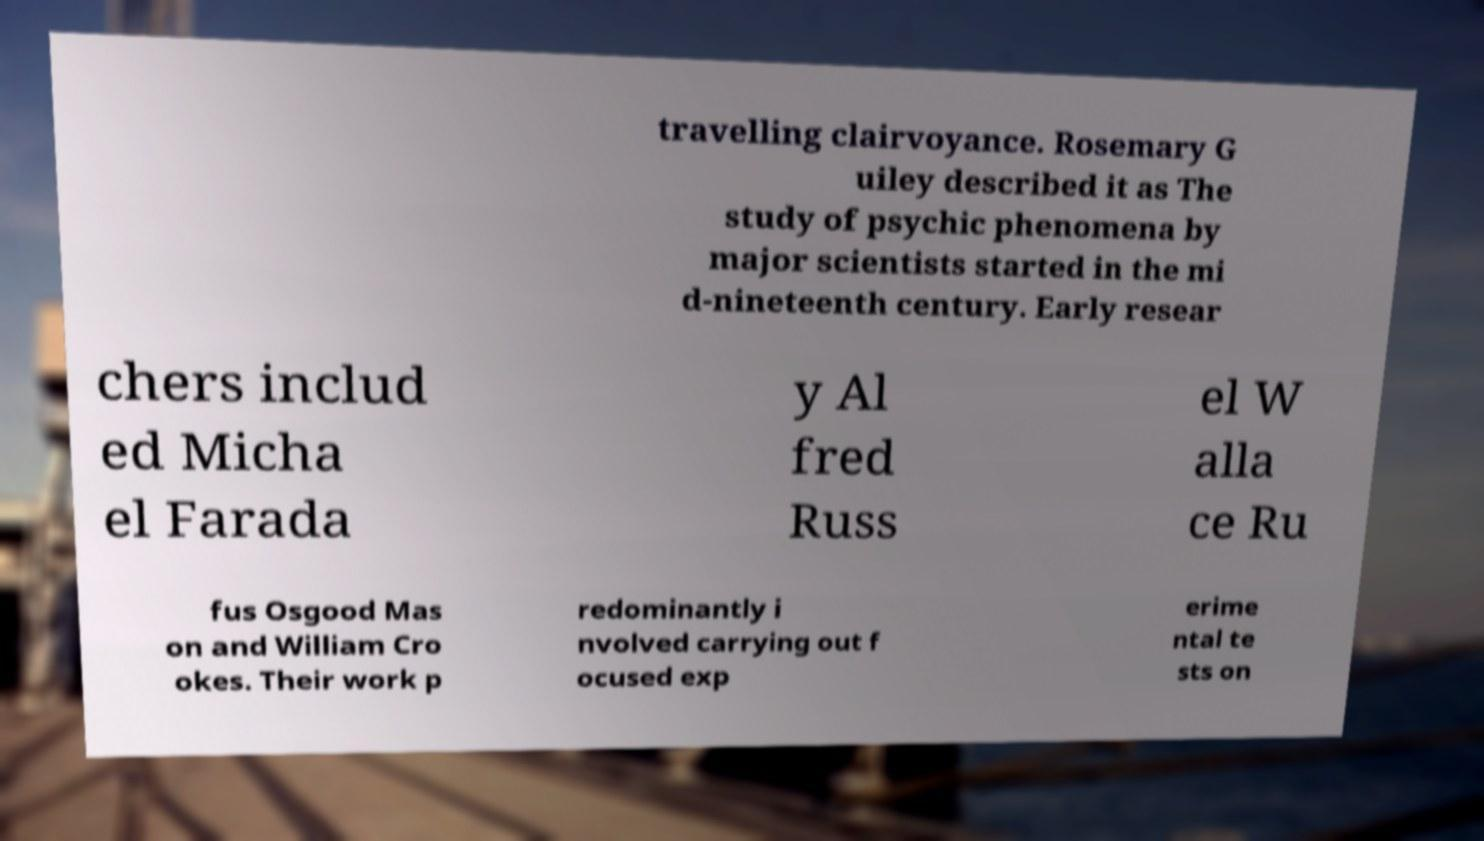There's text embedded in this image that I need extracted. Can you transcribe it verbatim? travelling clairvoyance. Rosemary G uiley described it as The study of psychic phenomena by major scientists started in the mi d-nineteenth century. Early resear chers includ ed Micha el Farada y Al fred Russ el W alla ce Ru fus Osgood Mas on and William Cro okes. Their work p redominantly i nvolved carrying out f ocused exp erime ntal te sts on 